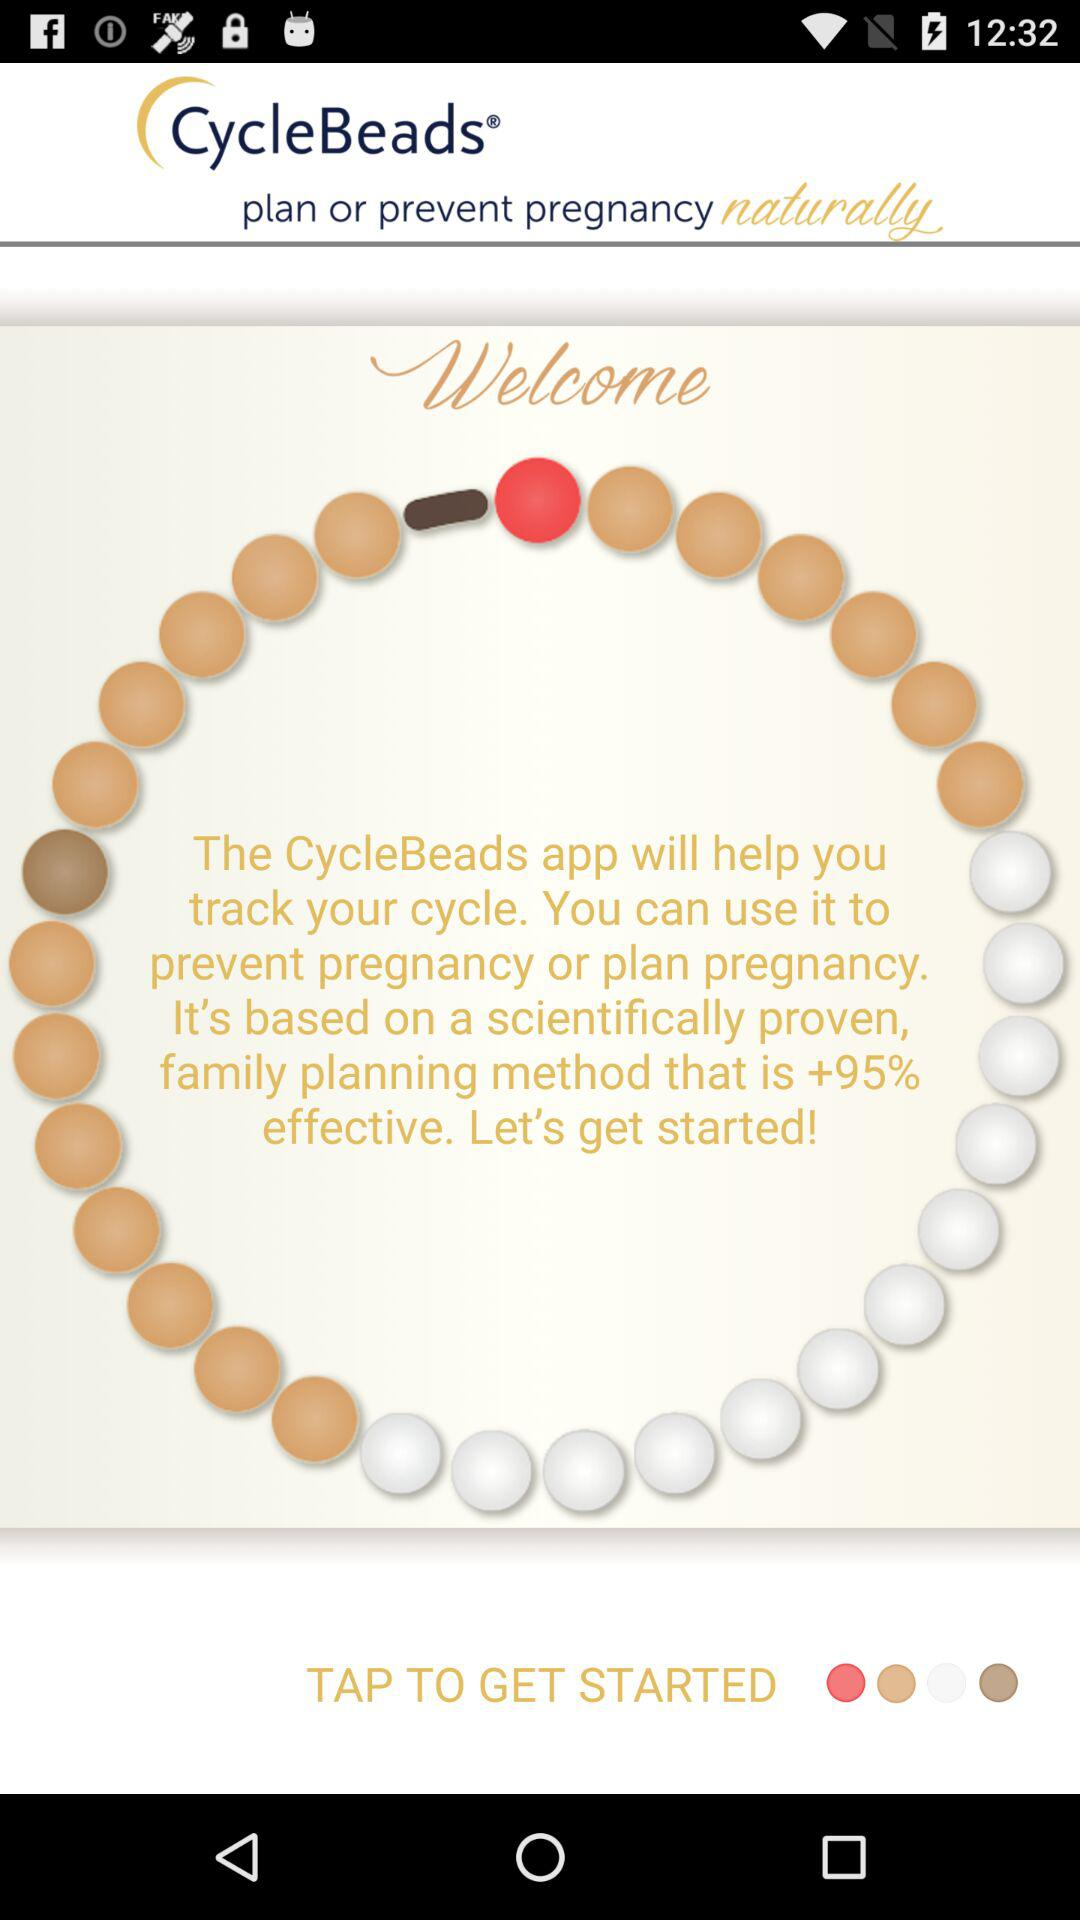How is CycleBeads helpful? CycleBeads will help you track your cycle. You can use it to prevent pregnancy or plan a pregnancy. 